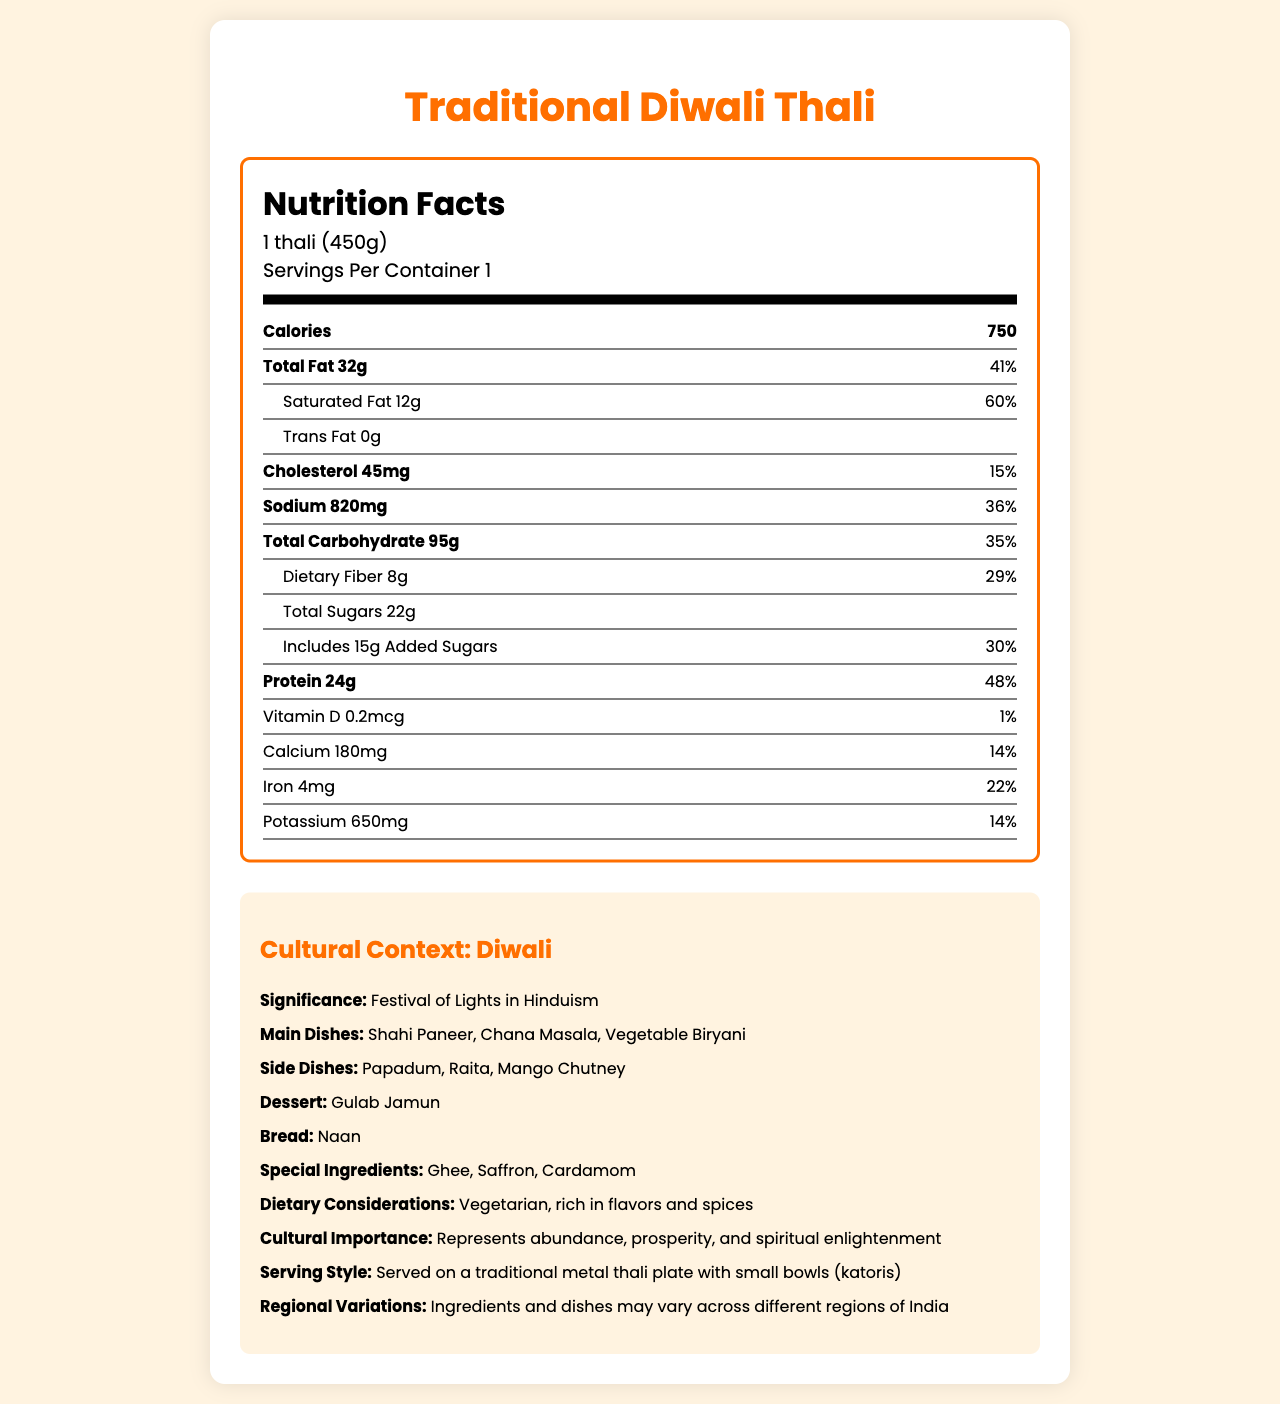what is the serving size of the Traditional Diwali Thali? The serving size is clearly indicated in the document as "1 thali (450g)".
Answer: 1 thali (450g) how many calories are there per serving? The document states that each serving contains 750 calories.
Answer: 750 what are the three main dishes included in the Traditional Diwali Thali? The main dishes are listed under the cultural context section.
Answer: Shahi Paneer, Chana Masala, Vegetable Biryani how much sodium is in one thali? The sodium content per serving is specified as 820 mg.
Answer: 820 mg what percent of daily value does the total fat in one thali represent? The document shows that the total fat of 32g corresponds to 41% of the daily value.
Answer: 41% which of the following is not a side dish in the Traditional Diwali Thali? A. Papadum B. Raita C. Mango Chutney D. Naan Naan is listed as a bread, not a side dish in the thali.
Answer: D. Naan what percentage of daily iron value does the thali provide? A. 10% B. 22% C. 35% D. 50% The document states that the iron content is 4 mg, which is 22% of the daily value.
Answer: B. 22% is the Traditional Diwali Thali a vegetarian meal? The cultural context section mentions that the thali is vegetarian.
Answer: Yes describe the cultural context section of the document. The cultural context section provides comprehensive details about the Traditional Diwali Thali, highlighting its relevance to the Diwali festival and its components.
Answer: The cultural context section explains the significance of Diwali, the festival for which this thali is prepared. It lists the main and side dishes, the dessert, the bread, and special ingredients used. It also describes the dietary considerations, cultural importance, serving style, and regional variations of the meal. what special ingredients are used in the Traditional Diwali Thali? The document lists ghee, saffron, and cardamom as special ingredients used in the thali.
Answer: Ghee, Saffron, Cardamom how much dietary fiber is there in one thali? The document specifies that there are 8 grams of dietary fiber in each serving.
Answer: 8g how is the thali typically served? The document mentions that the serving style is on a traditional metal thali plate with small bowls, known as katoris.
Answer: On a traditional metal thali plate with small bowls (katoris) what is the festival for which the Traditional Diwali Thali is prepared? The document states that the thali is prepared for the Diwali festival, also known as the Festival of Lights in Hinduism.
Answer: Diwali does the thali contain any trans fat? The document indicates that the trans fat content is 0g.
Answer: No what are the main dishes in the Traditional Diwali Thali? The cultural context section lists Shahi Paneer, Chana Masala, and Vegetable Biryani as the main dishes included in the thali.
Answer: Shahi Paneer, Chana Masala, Vegetable Biryani what is the total amount of sugars in one thali? The document shows that the total sugars amount to 22 grams per serving.
Answer: 22g what is the potassium content in one thali? The potassium content per serving is specified as 650 mg in the document.
Answer: 650mg how much vitamin D does the thali provide? The document indicates that each serving contains 0.2 mcg of vitamin D.
Answer: 0.2 mcg what is the daily value percentage of protein provided by one thali? The document shows that the protein content of 24g corresponds to 48% of the daily value.
Answer: 48% what is the primary dessert included in the Traditional Diwali Thali? The cultural context section lists Gulab Jamun as the dessert included in the thali.
Answer: Gulab Jamun what is the significance of Diwali? The document states that Diwali is the Festival of Lights in Hinduism, celebrating abundance, prosperity, and spiritual enlightenment.
Answer: Festival of Lights in Hinduism how does the nutritional content vary if the ingredients change based on regional variations? The document does mention regional variations but does not provide specific details on how these would affect the nutritional content.
Answer: Cannot be determined 